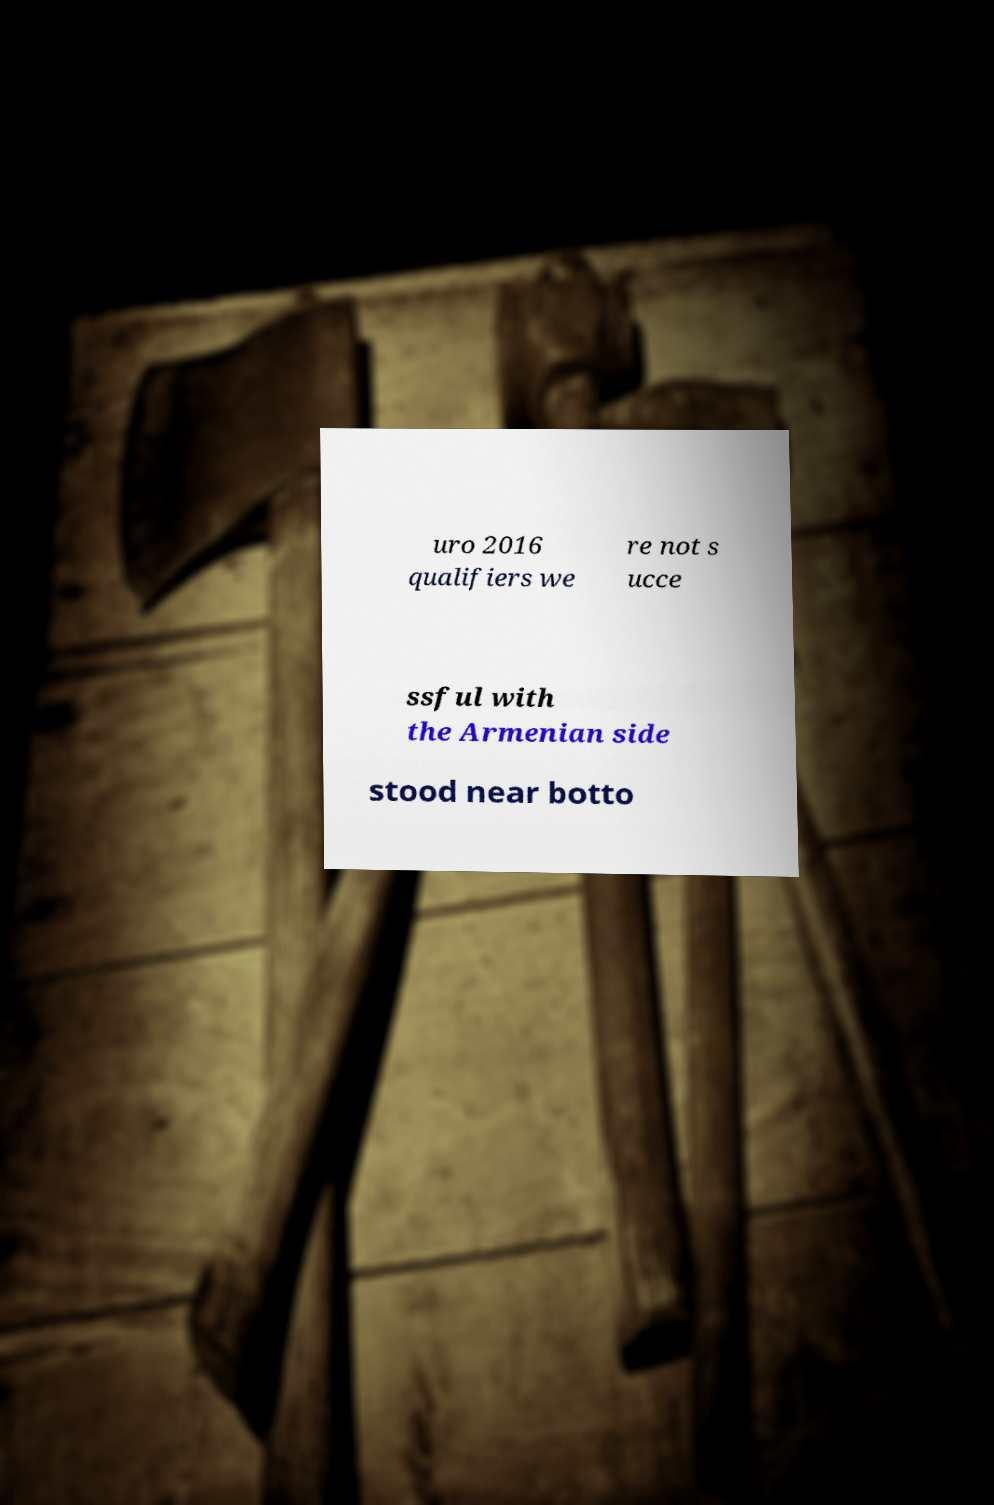Can you accurately transcribe the text from the provided image for me? uro 2016 qualifiers we re not s ucce ssful with the Armenian side stood near botto 